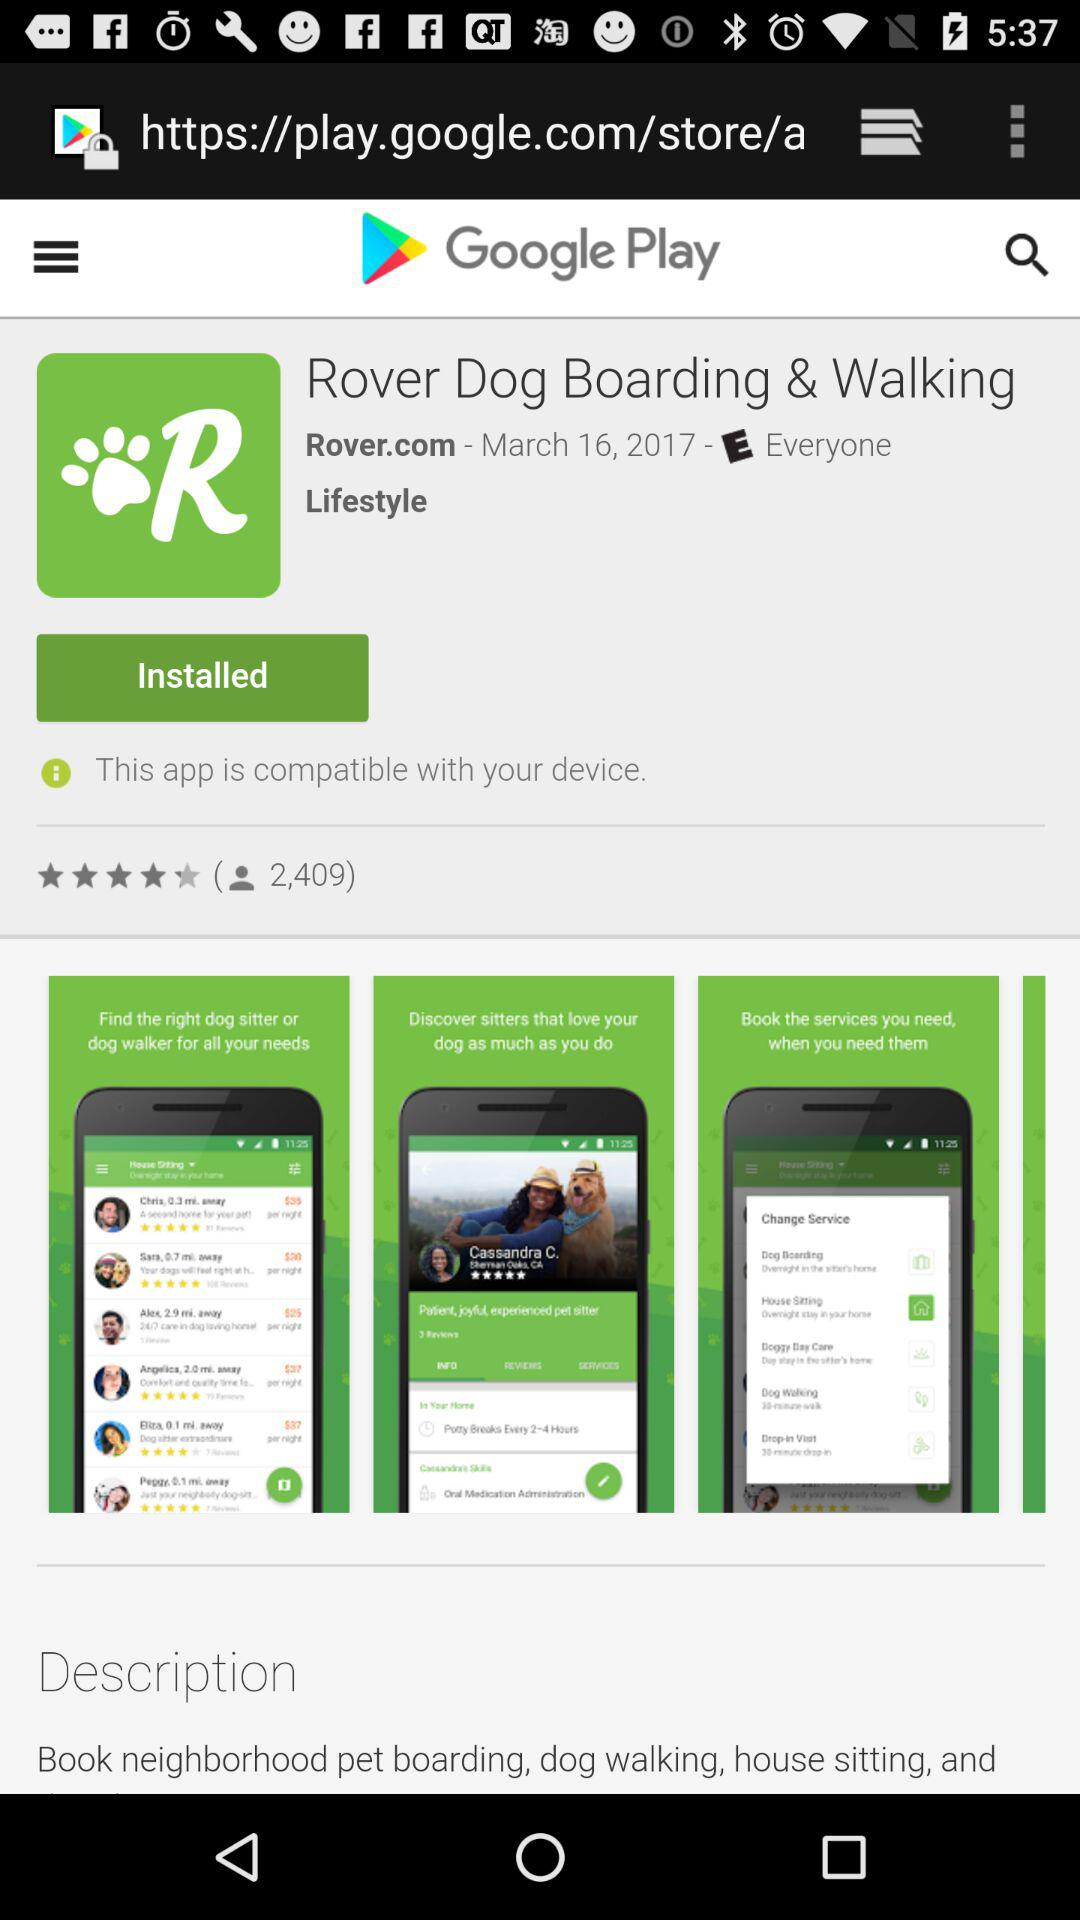What is the rating?
Answer the question using a single word or phrase. The rating is 4.5 stars 